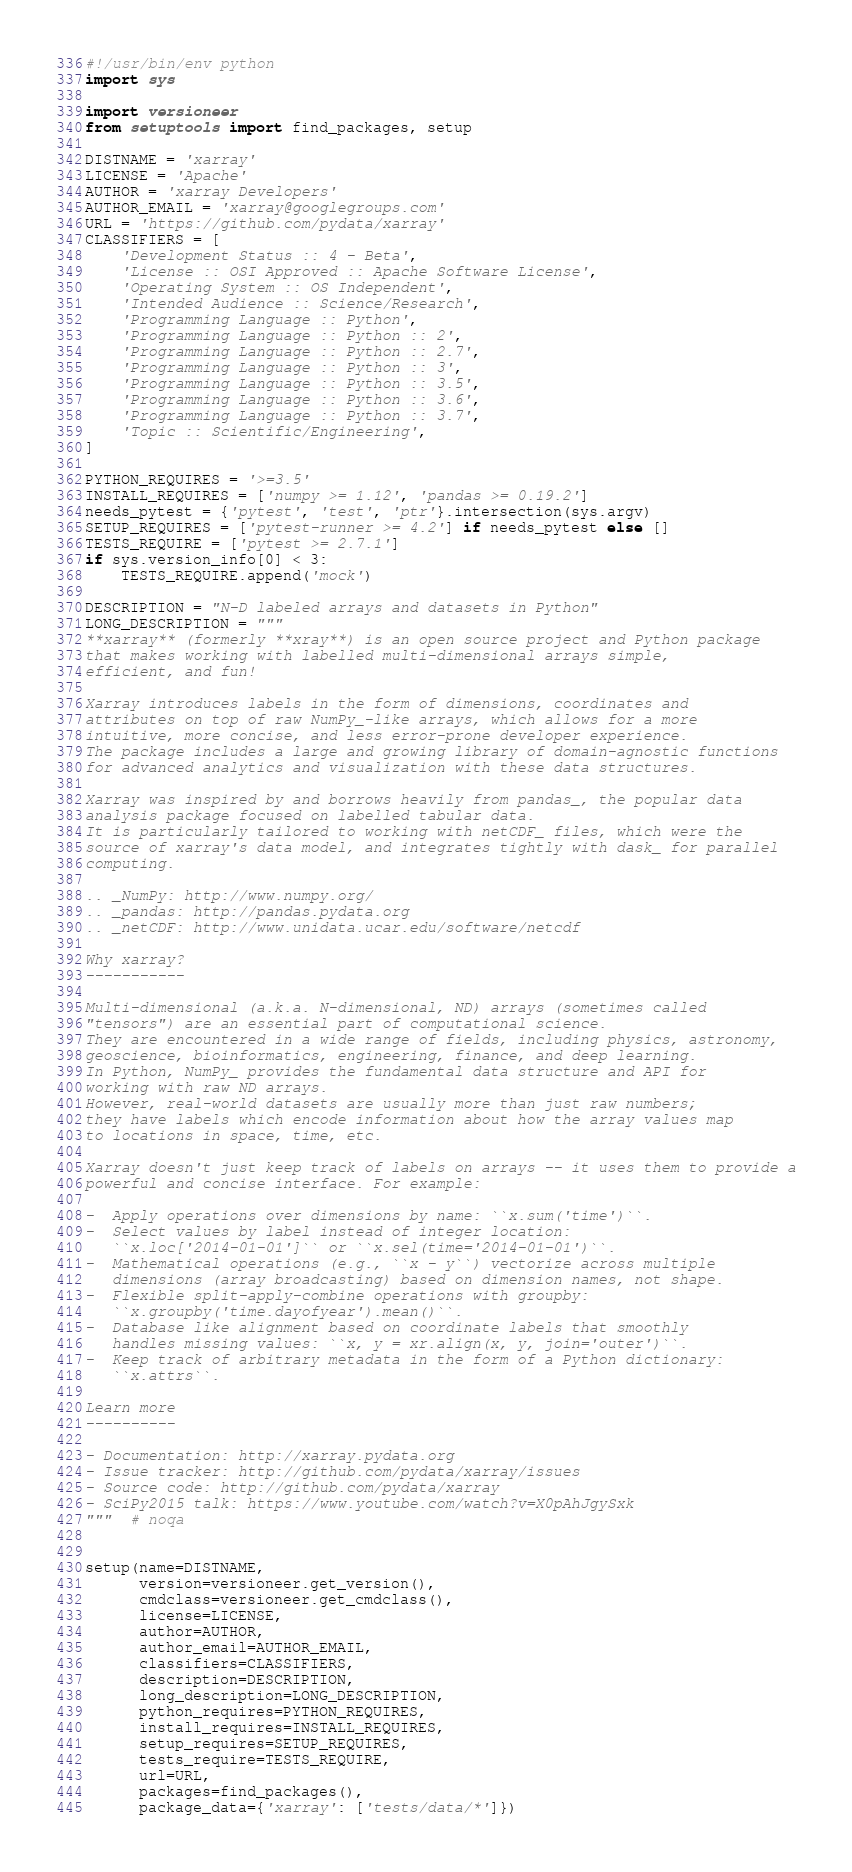Convert code to text. <code><loc_0><loc_0><loc_500><loc_500><_Python_>#!/usr/bin/env python
import sys

import versioneer
from setuptools import find_packages, setup

DISTNAME = 'xarray'
LICENSE = 'Apache'
AUTHOR = 'xarray Developers'
AUTHOR_EMAIL = 'xarray@googlegroups.com'
URL = 'https://github.com/pydata/xarray'
CLASSIFIERS = [
    'Development Status :: 4 - Beta',
    'License :: OSI Approved :: Apache Software License',
    'Operating System :: OS Independent',
    'Intended Audience :: Science/Research',
    'Programming Language :: Python',
    'Programming Language :: Python :: 2',
    'Programming Language :: Python :: 2.7',
    'Programming Language :: Python :: 3',
    'Programming Language :: Python :: 3.5',
    'Programming Language :: Python :: 3.6',
    'Programming Language :: Python :: 3.7',
    'Topic :: Scientific/Engineering',
]

PYTHON_REQUIRES = '>=3.5'
INSTALL_REQUIRES = ['numpy >= 1.12', 'pandas >= 0.19.2']
needs_pytest = {'pytest', 'test', 'ptr'}.intersection(sys.argv)
SETUP_REQUIRES = ['pytest-runner >= 4.2'] if needs_pytest else []
TESTS_REQUIRE = ['pytest >= 2.7.1']
if sys.version_info[0] < 3:
    TESTS_REQUIRE.append('mock')

DESCRIPTION = "N-D labeled arrays and datasets in Python"
LONG_DESCRIPTION = """
**xarray** (formerly **xray**) is an open source project and Python package
that makes working with labelled multi-dimensional arrays simple,
efficient, and fun!

Xarray introduces labels in the form of dimensions, coordinates and
attributes on top of raw NumPy_-like arrays, which allows for a more
intuitive, more concise, and less error-prone developer experience.
The package includes a large and growing library of domain-agnostic functions
for advanced analytics and visualization with these data structures.

Xarray was inspired by and borrows heavily from pandas_, the popular data
analysis package focused on labelled tabular data.
It is particularly tailored to working with netCDF_ files, which were the
source of xarray's data model, and integrates tightly with dask_ for parallel
computing.

.. _NumPy: http://www.numpy.org/
.. _pandas: http://pandas.pydata.org
.. _netCDF: http://www.unidata.ucar.edu/software/netcdf

Why xarray?
-----------

Multi-dimensional (a.k.a. N-dimensional, ND) arrays (sometimes called
"tensors") are an essential part of computational science.
They are encountered in a wide range of fields, including physics, astronomy,
geoscience, bioinformatics, engineering, finance, and deep learning.
In Python, NumPy_ provides the fundamental data structure and API for
working with raw ND arrays.
However, real-world datasets are usually more than just raw numbers;
they have labels which encode information about how the array values map
to locations in space, time, etc.

Xarray doesn't just keep track of labels on arrays -- it uses them to provide a
powerful and concise interface. For example:

-  Apply operations over dimensions by name: ``x.sum('time')``.
-  Select values by label instead of integer location:
   ``x.loc['2014-01-01']`` or ``x.sel(time='2014-01-01')``.
-  Mathematical operations (e.g., ``x - y``) vectorize across multiple
   dimensions (array broadcasting) based on dimension names, not shape.
-  Flexible split-apply-combine operations with groupby:
   ``x.groupby('time.dayofyear').mean()``.
-  Database like alignment based on coordinate labels that smoothly
   handles missing values: ``x, y = xr.align(x, y, join='outer')``.
-  Keep track of arbitrary metadata in the form of a Python dictionary:
   ``x.attrs``.

Learn more
----------

- Documentation: http://xarray.pydata.org
- Issue tracker: http://github.com/pydata/xarray/issues
- Source code: http://github.com/pydata/xarray
- SciPy2015 talk: https://www.youtube.com/watch?v=X0pAhJgySxk
"""  # noqa


setup(name=DISTNAME,
      version=versioneer.get_version(),
      cmdclass=versioneer.get_cmdclass(),
      license=LICENSE,
      author=AUTHOR,
      author_email=AUTHOR_EMAIL,
      classifiers=CLASSIFIERS,
      description=DESCRIPTION,
      long_description=LONG_DESCRIPTION,
      python_requires=PYTHON_REQUIRES,
      install_requires=INSTALL_REQUIRES,
      setup_requires=SETUP_REQUIRES,
      tests_require=TESTS_REQUIRE,
      url=URL,
      packages=find_packages(),
      package_data={'xarray': ['tests/data/*']})
</code> 